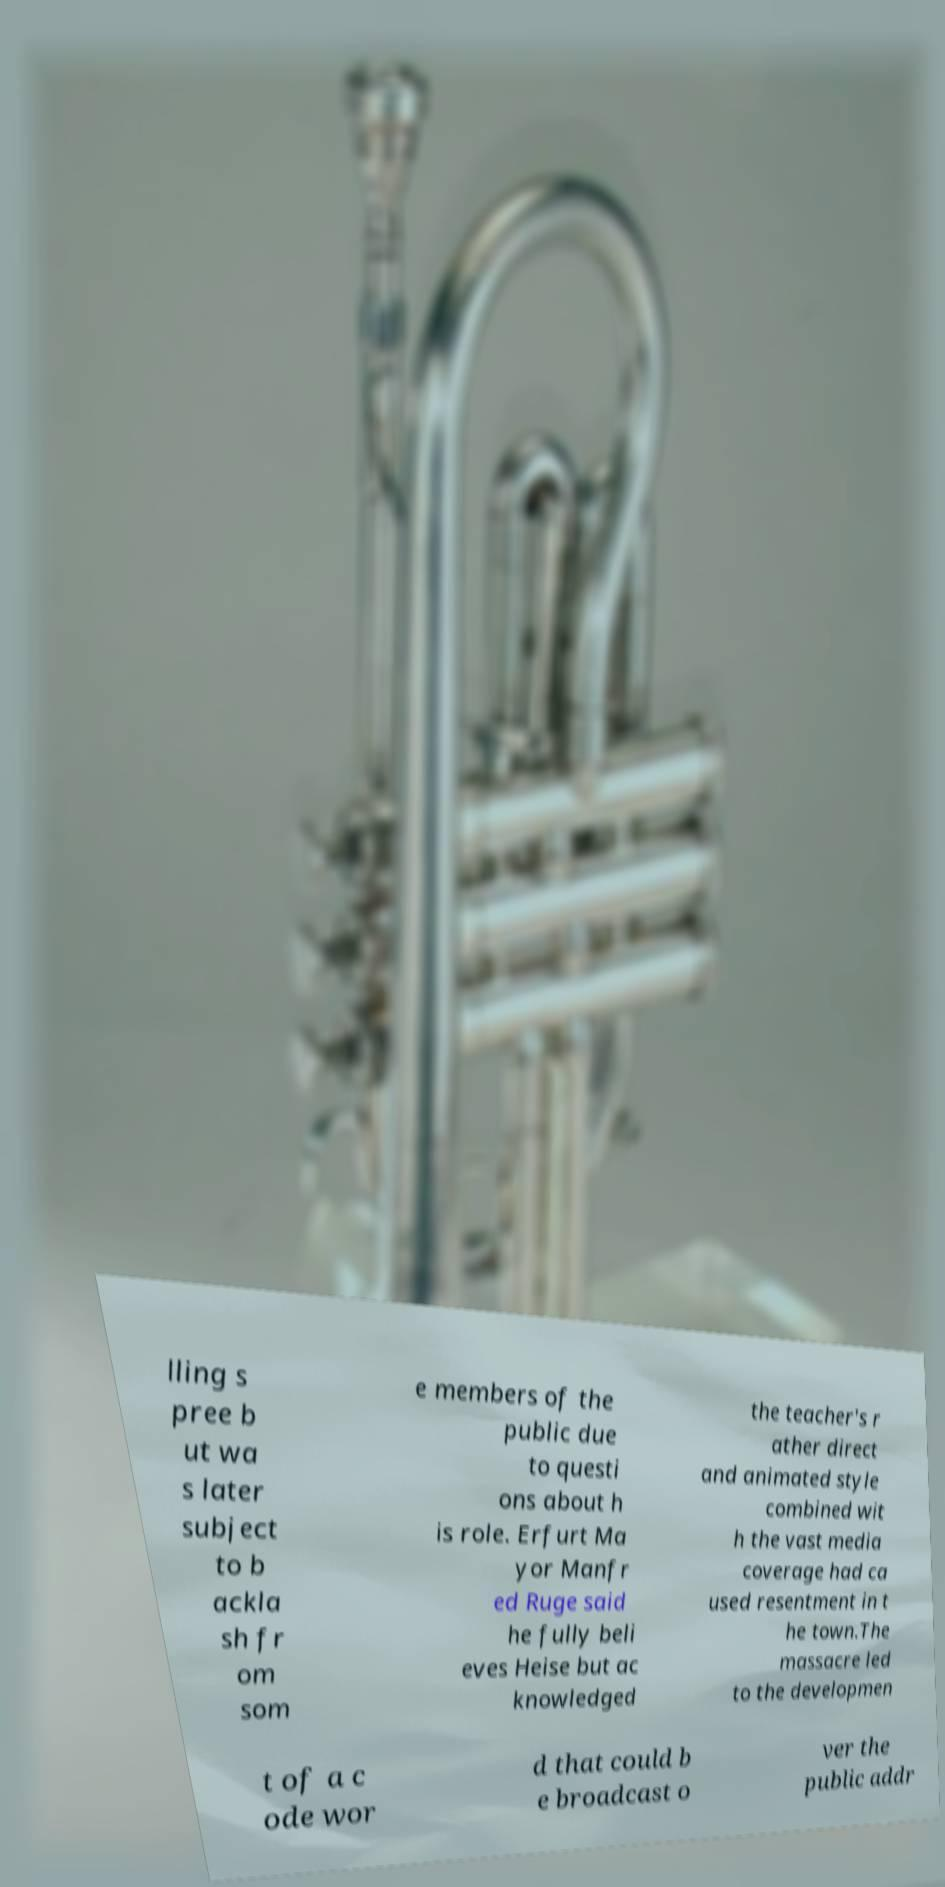Could you extract and type out the text from this image? lling s pree b ut wa s later subject to b ackla sh fr om som e members of the public due to questi ons about h is role. Erfurt Ma yor Manfr ed Ruge said he fully beli eves Heise but ac knowledged the teacher's r ather direct and animated style combined wit h the vast media coverage had ca used resentment in t he town.The massacre led to the developmen t of a c ode wor d that could b e broadcast o ver the public addr 